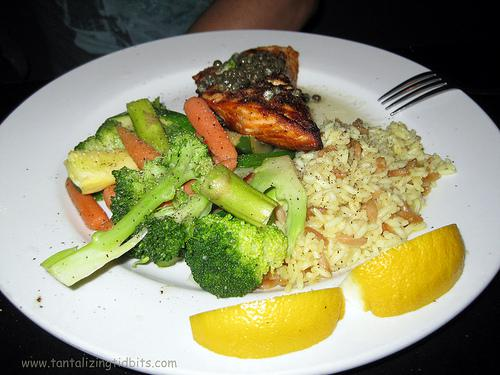Question: when was this picture taken?
Choices:
A. At meal time.
B. Sunset.
C. Sunrise.
D. Night.
Answer with the letter. Answer: A Question: what color are the lemons?
Choices:
A. Red.
B. Yellow.
C. White.
D. Blue.
Answer with the letter. Answer: B Question: how many people are in the picture?
Choices:
A. One.
B. Two.
C. Three.
D. None.
Answer with the letter. Answer: D Question: what is this a picture of?
Choices:
A. A child.
B. Food.
C. A car.
D. A street.
Answer with the letter. Answer: B 